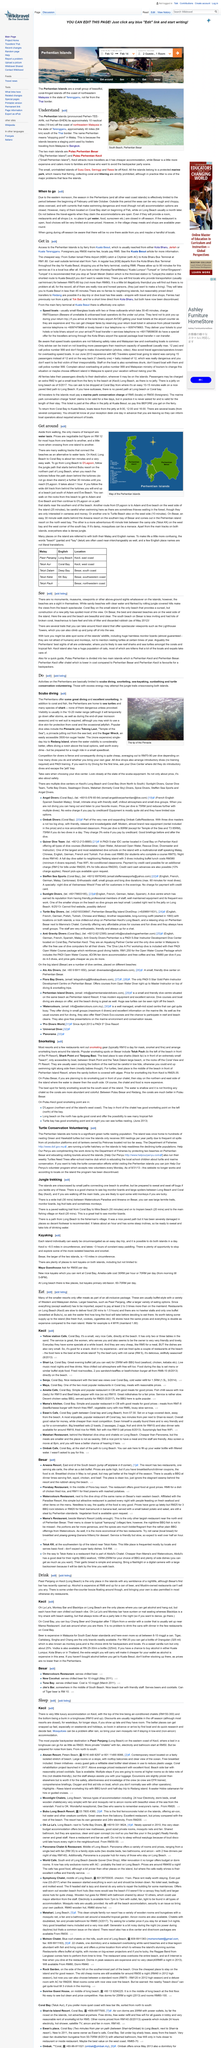Draw attention to some important aspects in this diagram. The west side of Besar Island boasts the best and cleanest beaches, making it the ideal destination for those seeking a relaxing and enjoyable coastal experience. Terengganu is approximately 40 miles from the Thai border. It is not necessary to wear a wet suit, but a dive skin may be desired to protect against jellyfish. The scuba diving trip to Red Island in the Perhentians offers significantly better water visibility compared to other diving locations in the area. Beginning in February, travelers can secure accommodations in Coral Bay for the upcoming tourist season, while those planning to visit Long Beach can typically start booking a month later. 